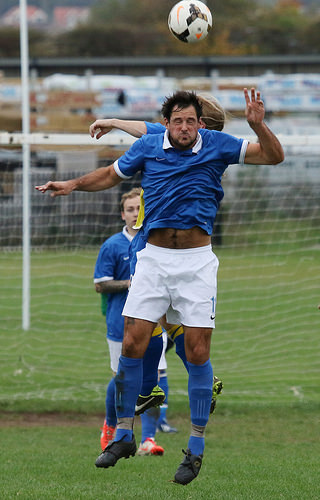<image>
Can you confirm if the man is under the ball? Yes. The man is positioned underneath the ball, with the ball above it in the vertical space. 